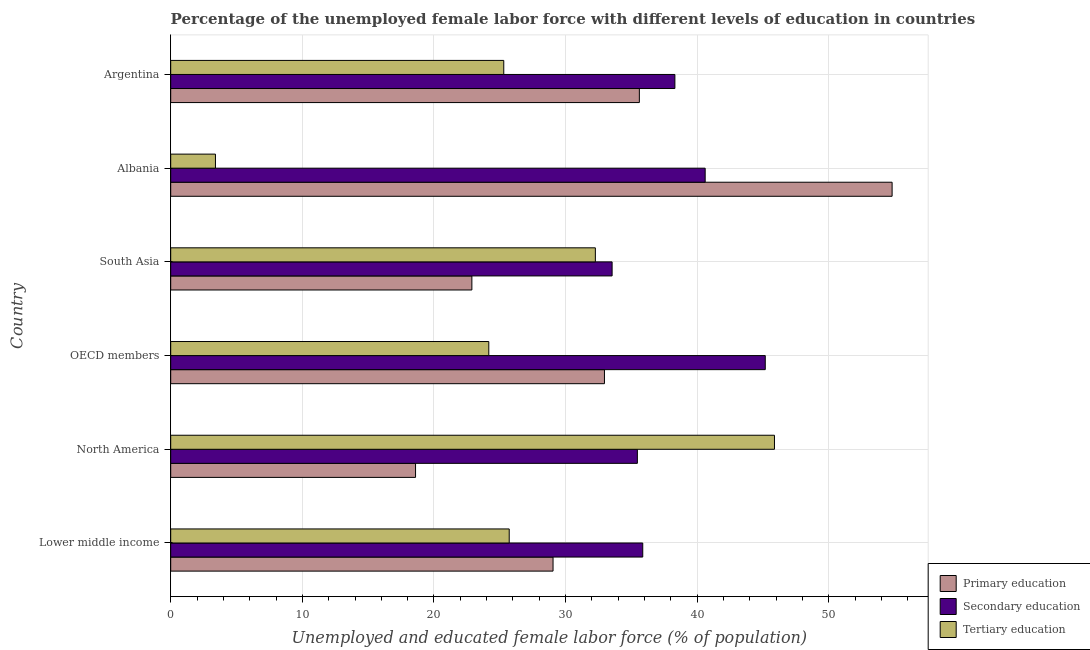How many different coloured bars are there?
Provide a short and direct response. 3. How many bars are there on the 6th tick from the top?
Offer a terse response. 3. How many bars are there on the 3rd tick from the bottom?
Give a very brief answer. 3. What is the label of the 5th group of bars from the top?
Make the answer very short. North America. What is the percentage of female labor force who received primary education in OECD members?
Your response must be concise. 32.95. Across all countries, what is the maximum percentage of female labor force who received secondary education?
Offer a terse response. 45.16. Across all countries, what is the minimum percentage of female labor force who received secondary education?
Your answer should be compact. 33.53. In which country was the percentage of female labor force who received tertiary education minimum?
Give a very brief answer. Albania. What is the total percentage of female labor force who received tertiary education in the graph?
Offer a terse response. 156.7. What is the difference between the percentage of female labor force who received secondary education in Lower middle income and that in North America?
Offer a very short reply. 0.41. What is the difference between the percentage of female labor force who received primary education in Albania and the percentage of female labor force who received tertiary education in North America?
Your answer should be compact. 8.94. What is the average percentage of female labor force who received tertiary education per country?
Offer a very short reply. 26.12. What is the difference between the percentage of female labor force who received secondary education and percentage of female labor force who received tertiary education in Lower middle income?
Offer a very short reply. 10.14. In how many countries, is the percentage of female labor force who received secondary education greater than 46 %?
Make the answer very short. 0. What is the ratio of the percentage of female labor force who received primary education in Lower middle income to that in North America?
Offer a terse response. 1.56. Is the difference between the percentage of female labor force who received primary education in Lower middle income and South Asia greater than the difference between the percentage of female labor force who received secondary education in Lower middle income and South Asia?
Ensure brevity in your answer.  Yes. What is the difference between the highest and the lowest percentage of female labor force who received primary education?
Ensure brevity in your answer.  36.2. What does the 2nd bar from the top in OECD members represents?
Offer a terse response. Secondary education. What does the 2nd bar from the bottom in North America represents?
Provide a short and direct response. Secondary education. How many bars are there?
Keep it short and to the point. 18. How many countries are there in the graph?
Ensure brevity in your answer.  6. What is the difference between two consecutive major ticks on the X-axis?
Provide a succinct answer. 10. Are the values on the major ticks of X-axis written in scientific E-notation?
Keep it short and to the point. No. Does the graph contain any zero values?
Provide a succinct answer. No. Does the graph contain grids?
Your answer should be compact. Yes. Where does the legend appear in the graph?
Your response must be concise. Bottom right. What is the title of the graph?
Provide a succinct answer. Percentage of the unemployed female labor force with different levels of education in countries. What is the label or title of the X-axis?
Give a very brief answer. Unemployed and educated female labor force (% of population). What is the label or title of the Y-axis?
Provide a short and direct response. Country. What is the Unemployed and educated female labor force (% of population) in Primary education in Lower middle income?
Keep it short and to the point. 29.04. What is the Unemployed and educated female labor force (% of population) in Secondary education in Lower middle income?
Your answer should be compact. 35.86. What is the Unemployed and educated female labor force (% of population) of Tertiary education in Lower middle income?
Give a very brief answer. 25.71. What is the Unemployed and educated female labor force (% of population) of Primary education in North America?
Your response must be concise. 18.6. What is the Unemployed and educated female labor force (% of population) of Secondary education in North America?
Offer a terse response. 35.45. What is the Unemployed and educated female labor force (% of population) in Tertiary education in North America?
Give a very brief answer. 45.86. What is the Unemployed and educated female labor force (% of population) in Primary education in OECD members?
Offer a terse response. 32.95. What is the Unemployed and educated female labor force (% of population) of Secondary education in OECD members?
Offer a very short reply. 45.16. What is the Unemployed and educated female labor force (% of population) in Tertiary education in OECD members?
Make the answer very short. 24.16. What is the Unemployed and educated female labor force (% of population) of Primary education in South Asia?
Your response must be concise. 22.88. What is the Unemployed and educated female labor force (% of population) in Secondary education in South Asia?
Provide a succinct answer. 33.53. What is the Unemployed and educated female labor force (% of population) of Tertiary education in South Asia?
Provide a short and direct response. 32.26. What is the Unemployed and educated female labor force (% of population) of Primary education in Albania?
Provide a succinct answer. 54.8. What is the Unemployed and educated female labor force (% of population) of Secondary education in Albania?
Your answer should be compact. 40.6. What is the Unemployed and educated female labor force (% of population) of Tertiary education in Albania?
Give a very brief answer. 3.4. What is the Unemployed and educated female labor force (% of population) of Primary education in Argentina?
Offer a terse response. 35.6. What is the Unemployed and educated female labor force (% of population) of Secondary education in Argentina?
Your answer should be very brief. 38.3. What is the Unemployed and educated female labor force (% of population) in Tertiary education in Argentina?
Ensure brevity in your answer.  25.3. Across all countries, what is the maximum Unemployed and educated female labor force (% of population) in Primary education?
Ensure brevity in your answer.  54.8. Across all countries, what is the maximum Unemployed and educated female labor force (% of population) of Secondary education?
Offer a terse response. 45.16. Across all countries, what is the maximum Unemployed and educated female labor force (% of population) in Tertiary education?
Your answer should be compact. 45.86. Across all countries, what is the minimum Unemployed and educated female labor force (% of population) of Primary education?
Your response must be concise. 18.6. Across all countries, what is the minimum Unemployed and educated female labor force (% of population) of Secondary education?
Offer a terse response. 33.53. Across all countries, what is the minimum Unemployed and educated female labor force (% of population) in Tertiary education?
Make the answer very short. 3.4. What is the total Unemployed and educated female labor force (% of population) in Primary education in the graph?
Keep it short and to the point. 193.87. What is the total Unemployed and educated female labor force (% of population) in Secondary education in the graph?
Your response must be concise. 228.9. What is the total Unemployed and educated female labor force (% of population) in Tertiary education in the graph?
Give a very brief answer. 156.7. What is the difference between the Unemployed and educated female labor force (% of population) of Primary education in Lower middle income and that in North America?
Ensure brevity in your answer.  10.44. What is the difference between the Unemployed and educated female labor force (% of population) of Secondary education in Lower middle income and that in North America?
Your answer should be very brief. 0.41. What is the difference between the Unemployed and educated female labor force (% of population) of Tertiary education in Lower middle income and that in North America?
Provide a short and direct response. -20.15. What is the difference between the Unemployed and educated female labor force (% of population) of Primary education in Lower middle income and that in OECD members?
Your response must be concise. -3.9. What is the difference between the Unemployed and educated female labor force (% of population) in Secondary education in Lower middle income and that in OECD members?
Make the answer very short. -9.31. What is the difference between the Unemployed and educated female labor force (% of population) of Tertiary education in Lower middle income and that in OECD members?
Your response must be concise. 1.55. What is the difference between the Unemployed and educated female labor force (% of population) in Primary education in Lower middle income and that in South Asia?
Ensure brevity in your answer.  6.17. What is the difference between the Unemployed and educated female labor force (% of population) in Secondary education in Lower middle income and that in South Asia?
Give a very brief answer. 2.33. What is the difference between the Unemployed and educated female labor force (% of population) of Tertiary education in Lower middle income and that in South Asia?
Your response must be concise. -6.54. What is the difference between the Unemployed and educated female labor force (% of population) of Primary education in Lower middle income and that in Albania?
Provide a short and direct response. -25.76. What is the difference between the Unemployed and educated female labor force (% of population) in Secondary education in Lower middle income and that in Albania?
Your answer should be very brief. -4.74. What is the difference between the Unemployed and educated female labor force (% of population) of Tertiary education in Lower middle income and that in Albania?
Make the answer very short. 22.31. What is the difference between the Unemployed and educated female labor force (% of population) of Primary education in Lower middle income and that in Argentina?
Your response must be concise. -6.56. What is the difference between the Unemployed and educated female labor force (% of population) in Secondary education in Lower middle income and that in Argentina?
Give a very brief answer. -2.44. What is the difference between the Unemployed and educated female labor force (% of population) of Tertiary education in Lower middle income and that in Argentina?
Your answer should be very brief. 0.41. What is the difference between the Unemployed and educated female labor force (% of population) in Primary education in North America and that in OECD members?
Provide a short and direct response. -14.35. What is the difference between the Unemployed and educated female labor force (% of population) of Secondary education in North America and that in OECD members?
Make the answer very short. -9.72. What is the difference between the Unemployed and educated female labor force (% of population) in Tertiary education in North America and that in OECD members?
Your response must be concise. 21.7. What is the difference between the Unemployed and educated female labor force (% of population) of Primary education in North America and that in South Asia?
Offer a very short reply. -4.28. What is the difference between the Unemployed and educated female labor force (% of population) of Secondary education in North America and that in South Asia?
Ensure brevity in your answer.  1.92. What is the difference between the Unemployed and educated female labor force (% of population) of Tertiary education in North America and that in South Asia?
Offer a very short reply. 13.61. What is the difference between the Unemployed and educated female labor force (% of population) of Primary education in North America and that in Albania?
Keep it short and to the point. -36.2. What is the difference between the Unemployed and educated female labor force (% of population) of Secondary education in North America and that in Albania?
Your answer should be compact. -5.15. What is the difference between the Unemployed and educated female labor force (% of population) of Tertiary education in North America and that in Albania?
Give a very brief answer. 42.46. What is the difference between the Unemployed and educated female labor force (% of population) in Primary education in North America and that in Argentina?
Your answer should be compact. -17. What is the difference between the Unemployed and educated female labor force (% of population) in Secondary education in North America and that in Argentina?
Offer a very short reply. -2.85. What is the difference between the Unemployed and educated female labor force (% of population) of Tertiary education in North America and that in Argentina?
Make the answer very short. 20.56. What is the difference between the Unemployed and educated female labor force (% of population) of Primary education in OECD members and that in South Asia?
Keep it short and to the point. 10.07. What is the difference between the Unemployed and educated female labor force (% of population) in Secondary education in OECD members and that in South Asia?
Give a very brief answer. 11.63. What is the difference between the Unemployed and educated female labor force (% of population) of Tertiary education in OECD members and that in South Asia?
Keep it short and to the point. -8.09. What is the difference between the Unemployed and educated female labor force (% of population) in Primary education in OECD members and that in Albania?
Keep it short and to the point. -21.85. What is the difference between the Unemployed and educated female labor force (% of population) in Secondary education in OECD members and that in Albania?
Offer a very short reply. 4.56. What is the difference between the Unemployed and educated female labor force (% of population) in Tertiary education in OECD members and that in Albania?
Offer a very short reply. 20.76. What is the difference between the Unemployed and educated female labor force (% of population) in Primary education in OECD members and that in Argentina?
Offer a terse response. -2.65. What is the difference between the Unemployed and educated female labor force (% of population) of Secondary education in OECD members and that in Argentina?
Provide a short and direct response. 6.86. What is the difference between the Unemployed and educated female labor force (% of population) in Tertiary education in OECD members and that in Argentina?
Give a very brief answer. -1.14. What is the difference between the Unemployed and educated female labor force (% of population) of Primary education in South Asia and that in Albania?
Provide a short and direct response. -31.92. What is the difference between the Unemployed and educated female labor force (% of population) in Secondary education in South Asia and that in Albania?
Your answer should be compact. -7.07. What is the difference between the Unemployed and educated female labor force (% of population) of Tertiary education in South Asia and that in Albania?
Offer a very short reply. 28.86. What is the difference between the Unemployed and educated female labor force (% of population) of Primary education in South Asia and that in Argentina?
Give a very brief answer. -12.72. What is the difference between the Unemployed and educated female labor force (% of population) of Secondary education in South Asia and that in Argentina?
Your answer should be compact. -4.77. What is the difference between the Unemployed and educated female labor force (% of population) of Tertiary education in South Asia and that in Argentina?
Your answer should be very brief. 6.96. What is the difference between the Unemployed and educated female labor force (% of population) in Secondary education in Albania and that in Argentina?
Ensure brevity in your answer.  2.3. What is the difference between the Unemployed and educated female labor force (% of population) in Tertiary education in Albania and that in Argentina?
Offer a very short reply. -21.9. What is the difference between the Unemployed and educated female labor force (% of population) in Primary education in Lower middle income and the Unemployed and educated female labor force (% of population) in Secondary education in North America?
Offer a very short reply. -6.41. What is the difference between the Unemployed and educated female labor force (% of population) in Primary education in Lower middle income and the Unemployed and educated female labor force (% of population) in Tertiary education in North America?
Provide a succinct answer. -16.82. What is the difference between the Unemployed and educated female labor force (% of population) in Secondary education in Lower middle income and the Unemployed and educated female labor force (% of population) in Tertiary education in North America?
Provide a short and direct response. -10.01. What is the difference between the Unemployed and educated female labor force (% of population) in Primary education in Lower middle income and the Unemployed and educated female labor force (% of population) in Secondary education in OECD members?
Offer a terse response. -16.12. What is the difference between the Unemployed and educated female labor force (% of population) of Primary education in Lower middle income and the Unemployed and educated female labor force (% of population) of Tertiary education in OECD members?
Provide a short and direct response. 4.88. What is the difference between the Unemployed and educated female labor force (% of population) of Secondary education in Lower middle income and the Unemployed and educated female labor force (% of population) of Tertiary education in OECD members?
Provide a succinct answer. 11.69. What is the difference between the Unemployed and educated female labor force (% of population) in Primary education in Lower middle income and the Unemployed and educated female labor force (% of population) in Secondary education in South Asia?
Your response must be concise. -4.49. What is the difference between the Unemployed and educated female labor force (% of population) of Primary education in Lower middle income and the Unemployed and educated female labor force (% of population) of Tertiary education in South Asia?
Your answer should be compact. -3.21. What is the difference between the Unemployed and educated female labor force (% of population) in Secondary education in Lower middle income and the Unemployed and educated female labor force (% of population) in Tertiary education in South Asia?
Offer a very short reply. 3.6. What is the difference between the Unemployed and educated female labor force (% of population) in Primary education in Lower middle income and the Unemployed and educated female labor force (% of population) in Secondary education in Albania?
Your answer should be compact. -11.56. What is the difference between the Unemployed and educated female labor force (% of population) of Primary education in Lower middle income and the Unemployed and educated female labor force (% of population) of Tertiary education in Albania?
Your answer should be very brief. 25.64. What is the difference between the Unemployed and educated female labor force (% of population) in Secondary education in Lower middle income and the Unemployed and educated female labor force (% of population) in Tertiary education in Albania?
Your response must be concise. 32.46. What is the difference between the Unemployed and educated female labor force (% of population) of Primary education in Lower middle income and the Unemployed and educated female labor force (% of population) of Secondary education in Argentina?
Ensure brevity in your answer.  -9.26. What is the difference between the Unemployed and educated female labor force (% of population) of Primary education in Lower middle income and the Unemployed and educated female labor force (% of population) of Tertiary education in Argentina?
Offer a very short reply. 3.74. What is the difference between the Unemployed and educated female labor force (% of population) of Secondary education in Lower middle income and the Unemployed and educated female labor force (% of population) of Tertiary education in Argentina?
Your response must be concise. 10.56. What is the difference between the Unemployed and educated female labor force (% of population) of Primary education in North America and the Unemployed and educated female labor force (% of population) of Secondary education in OECD members?
Your response must be concise. -26.57. What is the difference between the Unemployed and educated female labor force (% of population) of Primary education in North America and the Unemployed and educated female labor force (% of population) of Tertiary education in OECD members?
Your answer should be very brief. -5.56. What is the difference between the Unemployed and educated female labor force (% of population) of Secondary education in North America and the Unemployed and educated female labor force (% of population) of Tertiary education in OECD members?
Your answer should be compact. 11.29. What is the difference between the Unemployed and educated female labor force (% of population) of Primary education in North America and the Unemployed and educated female labor force (% of population) of Secondary education in South Asia?
Provide a succinct answer. -14.93. What is the difference between the Unemployed and educated female labor force (% of population) of Primary education in North America and the Unemployed and educated female labor force (% of population) of Tertiary education in South Asia?
Your response must be concise. -13.66. What is the difference between the Unemployed and educated female labor force (% of population) of Secondary education in North America and the Unemployed and educated female labor force (% of population) of Tertiary education in South Asia?
Your answer should be compact. 3.19. What is the difference between the Unemployed and educated female labor force (% of population) of Primary education in North America and the Unemployed and educated female labor force (% of population) of Secondary education in Albania?
Offer a terse response. -22. What is the difference between the Unemployed and educated female labor force (% of population) in Primary education in North America and the Unemployed and educated female labor force (% of population) in Tertiary education in Albania?
Keep it short and to the point. 15.2. What is the difference between the Unemployed and educated female labor force (% of population) of Secondary education in North America and the Unemployed and educated female labor force (% of population) of Tertiary education in Albania?
Make the answer very short. 32.05. What is the difference between the Unemployed and educated female labor force (% of population) in Primary education in North America and the Unemployed and educated female labor force (% of population) in Secondary education in Argentina?
Your answer should be compact. -19.7. What is the difference between the Unemployed and educated female labor force (% of population) of Primary education in North America and the Unemployed and educated female labor force (% of population) of Tertiary education in Argentina?
Provide a succinct answer. -6.7. What is the difference between the Unemployed and educated female labor force (% of population) of Secondary education in North America and the Unemployed and educated female labor force (% of population) of Tertiary education in Argentina?
Give a very brief answer. 10.15. What is the difference between the Unemployed and educated female labor force (% of population) in Primary education in OECD members and the Unemployed and educated female labor force (% of population) in Secondary education in South Asia?
Offer a terse response. -0.58. What is the difference between the Unemployed and educated female labor force (% of population) of Primary education in OECD members and the Unemployed and educated female labor force (% of population) of Tertiary education in South Asia?
Provide a short and direct response. 0.69. What is the difference between the Unemployed and educated female labor force (% of population) of Secondary education in OECD members and the Unemployed and educated female labor force (% of population) of Tertiary education in South Asia?
Your answer should be compact. 12.91. What is the difference between the Unemployed and educated female labor force (% of population) of Primary education in OECD members and the Unemployed and educated female labor force (% of population) of Secondary education in Albania?
Provide a short and direct response. -7.65. What is the difference between the Unemployed and educated female labor force (% of population) of Primary education in OECD members and the Unemployed and educated female labor force (% of population) of Tertiary education in Albania?
Provide a short and direct response. 29.55. What is the difference between the Unemployed and educated female labor force (% of population) of Secondary education in OECD members and the Unemployed and educated female labor force (% of population) of Tertiary education in Albania?
Provide a short and direct response. 41.76. What is the difference between the Unemployed and educated female labor force (% of population) of Primary education in OECD members and the Unemployed and educated female labor force (% of population) of Secondary education in Argentina?
Make the answer very short. -5.35. What is the difference between the Unemployed and educated female labor force (% of population) in Primary education in OECD members and the Unemployed and educated female labor force (% of population) in Tertiary education in Argentina?
Keep it short and to the point. 7.65. What is the difference between the Unemployed and educated female labor force (% of population) in Secondary education in OECD members and the Unemployed and educated female labor force (% of population) in Tertiary education in Argentina?
Make the answer very short. 19.86. What is the difference between the Unemployed and educated female labor force (% of population) in Primary education in South Asia and the Unemployed and educated female labor force (% of population) in Secondary education in Albania?
Keep it short and to the point. -17.72. What is the difference between the Unemployed and educated female labor force (% of population) of Primary education in South Asia and the Unemployed and educated female labor force (% of population) of Tertiary education in Albania?
Make the answer very short. 19.48. What is the difference between the Unemployed and educated female labor force (% of population) in Secondary education in South Asia and the Unemployed and educated female labor force (% of population) in Tertiary education in Albania?
Offer a very short reply. 30.13. What is the difference between the Unemployed and educated female labor force (% of population) in Primary education in South Asia and the Unemployed and educated female labor force (% of population) in Secondary education in Argentina?
Offer a terse response. -15.42. What is the difference between the Unemployed and educated female labor force (% of population) of Primary education in South Asia and the Unemployed and educated female labor force (% of population) of Tertiary education in Argentina?
Provide a short and direct response. -2.42. What is the difference between the Unemployed and educated female labor force (% of population) in Secondary education in South Asia and the Unemployed and educated female labor force (% of population) in Tertiary education in Argentina?
Ensure brevity in your answer.  8.23. What is the difference between the Unemployed and educated female labor force (% of population) of Primary education in Albania and the Unemployed and educated female labor force (% of population) of Secondary education in Argentina?
Your answer should be very brief. 16.5. What is the difference between the Unemployed and educated female labor force (% of population) of Primary education in Albania and the Unemployed and educated female labor force (% of population) of Tertiary education in Argentina?
Give a very brief answer. 29.5. What is the difference between the Unemployed and educated female labor force (% of population) of Secondary education in Albania and the Unemployed and educated female labor force (% of population) of Tertiary education in Argentina?
Make the answer very short. 15.3. What is the average Unemployed and educated female labor force (% of population) in Primary education per country?
Provide a succinct answer. 32.31. What is the average Unemployed and educated female labor force (% of population) of Secondary education per country?
Make the answer very short. 38.15. What is the average Unemployed and educated female labor force (% of population) in Tertiary education per country?
Give a very brief answer. 26.12. What is the difference between the Unemployed and educated female labor force (% of population) in Primary education and Unemployed and educated female labor force (% of population) in Secondary education in Lower middle income?
Provide a succinct answer. -6.81. What is the difference between the Unemployed and educated female labor force (% of population) of Primary education and Unemployed and educated female labor force (% of population) of Tertiary education in Lower middle income?
Your answer should be very brief. 3.33. What is the difference between the Unemployed and educated female labor force (% of population) in Secondary education and Unemployed and educated female labor force (% of population) in Tertiary education in Lower middle income?
Provide a short and direct response. 10.14. What is the difference between the Unemployed and educated female labor force (% of population) in Primary education and Unemployed and educated female labor force (% of population) in Secondary education in North America?
Offer a terse response. -16.85. What is the difference between the Unemployed and educated female labor force (% of population) in Primary education and Unemployed and educated female labor force (% of population) in Tertiary education in North America?
Offer a terse response. -27.26. What is the difference between the Unemployed and educated female labor force (% of population) in Secondary education and Unemployed and educated female labor force (% of population) in Tertiary education in North America?
Keep it short and to the point. -10.41. What is the difference between the Unemployed and educated female labor force (% of population) of Primary education and Unemployed and educated female labor force (% of population) of Secondary education in OECD members?
Your answer should be very brief. -12.22. What is the difference between the Unemployed and educated female labor force (% of population) of Primary education and Unemployed and educated female labor force (% of population) of Tertiary education in OECD members?
Give a very brief answer. 8.78. What is the difference between the Unemployed and educated female labor force (% of population) of Secondary education and Unemployed and educated female labor force (% of population) of Tertiary education in OECD members?
Provide a succinct answer. 21. What is the difference between the Unemployed and educated female labor force (% of population) in Primary education and Unemployed and educated female labor force (% of population) in Secondary education in South Asia?
Your response must be concise. -10.65. What is the difference between the Unemployed and educated female labor force (% of population) in Primary education and Unemployed and educated female labor force (% of population) in Tertiary education in South Asia?
Offer a terse response. -9.38. What is the difference between the Unemployed and educated female labor force (% of population) of Secondary education and Unemployed and educated female labor force (% of population) of Tertiary education in South Asia?
Your answer should be very brief. 1.27. What is the difference between the Unemployed and educated female labor force (% of population) of Primary education and Unemployed and educated female labor force (% of population) of Tertiary education in Albania?
Your response must be concise. 51.4. What is the difference between the Unemployed and educated female labor force (% of population) of Secondary education and Unemployed and educated female labor force (% of population) of Tertiary education in Albania?
Your response must be concise. 37.2. What is the difference between the Unemployed and educated female labor force (% of population) in Primary education and Unemployed and educated female labor force (% of population) in Tertiary education in Argentina?
Your answer should be very brief. 10.3. What is the ratio of the Unemployed and educated female labor force (% of population) in Primary education in Lower middle income to that in North America?
Provide a short and direct response. 1.56. What is the ratio of the Unemployed and educated female labor force (% of population) in Secondary education in Lower middle income to that in North America?
Make the answer very short. 1.01. What is the ratio of the Unemployed and educated female labor force (% of population) in Tertiary education in Lower middle income to that in North America?
Ensure brevity in your answer.  0.56. What is the ratio of the Unemployed and educated female labor force (% of population) of Primary education in Lower middle income to that in OECD members?
Your answer should be very brief. 0.88. What is the ratio of the Unemployed and educated female labor force (% of population) of Secondary education in Lower middle income to that in OECD members?
Your answer should be very brief. 0.79. What is the ratio of the Unemployed and educated female labor force (% of population) of Tertiary education in Lower middle income to that in OECD members?
Offer a very short reply. 1.06. What is the ratio of the Unemployed and educated female labor force (% of population) of Primary education in Lower middle income to that in South Asia?
Provide a short and direct response. 1.27. What is the ratio of the Unemployed and educated female labor force (% of population) in Secondary education in Lower middle income to that in South Asia?
Provide a succinct answer. 1.07. What is the ratio of the Unemployed and educated female labor force (% of population) in Tertiary education in Lower middle income to that in South Asia?
Keep it short and to the point. 0.8. What is the ratio of the Unemployed and educated female labor force (% of population) of Primary education in Lower middle income to that in Albania?
Provide a short and direct response. 0.53. What is the ratio of the Unemployed and educated female labor force (% of population) in Secondary education in Lower middle income to that in Albania?
Provide a short and direct response. 0.88. What is the ratio of the Unemployed and educated female labor force (% of population) in Tertiary education in Lower middle income to that in Albania?
Provide a short and direct response. 7.56. What is the ratio of the Unemployed and educated female labor force (% of population) in Primary education in Lower middle income to that in Argentina?
Keep it short and to the point. 0.82. What is the ratio of the Unemployed and educated female labor force (% of population) in Secondary education in Lower middle income to that in Argentina?
Offer a very short reply. 0.94. What is the ratio of the Unemployed and educated female labor force (% of population) in Tertiary education in Lower middle income to that in Argentina?
Make the answer very short. 1.02. What is the ratio of the Unemployed and educated female labor force (% of population) of Primary education in North America to that in OECD members?
Offer a very short reply. 0.56. What is the ratio of the Unemployed and educated female labor force (% of population) in Secondary education in North America to that in OECD members?
Ensure brevity in your answer.  0.78. What is the ratio of the Unemployed and educated female labor force (% of population) in Tertiary education in North America to that in OECD members?
Your answer should be very brief. 1.9. What is the ratio of the Unemployed and educated female labor force (% of population) of Primary education in North America to that in South Asia?
Your answer should be compact. 0.81. What is the ratio of the Unemployed and educated female labor force (% of population) of Secondary education in North America to that in South Asia?
Your answer should be very brief. 1.06. What is the ratio of the Unemployed and educated female labor force (% of population) of Tertiary education in North America to that in South Asia?
Your answer should be compact. 1.42. What is the ratio of the Unemployed and educated female labor force (% of population) in Primary education in North America to that in Albania?
Offer a very short reply. 0.34. What is the ratio of the Unemployed and educated female labor force (% of population) in Secondary education in North America to that in Albania?
Provide a short and direct response. 0.87. What is the ratio of the Unemployed and educated female labor force (% of population) of Tertiary education in North America to that in Albania?
Keep it short and to the point. 13.49. What is the ratio of the Unemployed and educated female labor force (% of population) in Primary education in North America to that in Argentina?
Keep it short and to the point. 0.52. What is the ratio of the Unemployed and educated female labor force (% of population) of Secondary education in North America to that in Argentina?
Your answer should be compact. 0.93. What is the ratio of the Unemployed and educated female labor force (% of population) in Tertiary education in North America to that in Argentina?
Offer a terse response. 1.81. What is the ratio of the Unemployed and educated female labor force (% of population) of Primary education in OECD members to that in South Asia?
Ensure brevity in your answer.  1.44. What is the ratio of the Unemployed and educated female labor force (% of population) of Secondary education in OECD members to that in South Asia?
Give a very brief answer. 1.35. What is the ratio of the Unemployed and educated female labor force (% of population) of Tertiary education in OECD members to that in South Asia?
Provide a succinct answer. 0.75. What is the ratio of the Unemployed and educated female labor force (% of population) of Primary education in OECD members to that in Albania?
Offer a very short reply. 0.6. What is the ratio of the Unemployed and educated female labor force (% of population) of Secondary education in OECD members to that in Albania?
Provide a short and direct response. 1.11. What is the ratio of the Unemployed and educated female labor force (% of population) in Tertiary education in OECD members to that in Albania?
Make the answer very short. 7.11. What is the ratio of the Unemployed and educated female labor force (% of population) of Primary education in OECD members to that in Argentina?
Ensure brevity in your answer.  0.93. What is the ratio of the Unemployed and educated female labor force (% of population) of Secondary education in OECD members to that in Argentina?
Offer a very short reply. 1.18. What is the ratio of the Unemployed and educated female labor force (% of population) of Tertiary education in OECD members to that in Argentina?
Your response must be concise. 0.96. What is the ratio of the Unemployed and educated female labor force (% of population) in Primary education in South Asia to that in Albania?
Your response must be concise. 0.42. What is the ratio of the Unemployed and educated female labor force (% of population) in Secondary education in South Asia to that in Albania?
Give a very brief answer. 0.83. What is the ratio of the Unemployed and educated female labor force (% of population) of Tertiary education in South Asia to that in Albania?
Provide a short and direct response. 9.49. What is the ratio of the Unemployed and educated female labor force (% of population) in Primary education in South Asia to that in Argentina?
Give a very brief answer. 0.64. What is the ratio of the Unemployed and educated female labor force (% of population) of Secondary education in South Asia to that in Argentina?
Give a very brief answer. 0.88. What is the ratio of the Unemployed and educated female labor force (% of population) of Tertiary education in South Asia to that in Argentina?
Offer a terse response. 1.27. What is the ratio of the Unemployed and educated female labor force (% of population) of Primary education in Albania to that in Argentina?
Your answer should be compact. 1.54. What is the ratio of the Unemployed and educated female labor force (% of population) of Secondary education in Albania to that in Argentina?
Give a very brief answer. 1.06. What is the ratio of the Unemployed and educated female labor force (% of population) in Tertiary education in Albania to that in Argentina?
Ensure brevity in your answer.  0.13. What is the difference between the highest and the second highest Unemployed and educated female labor force (% of population) in Primary education?
Provide a succinct answer. 19.2. What is the difference between the highest and the second highest Unemployed and educated female labor force (% of population) in Secondary education?
Your response must be concise. 4.56. What is the difference between the highest and the second highest Unemployed and educated female labor force (% of population) of Tertiary education?
Your answer should be compact. 13.61. What is the difference between the highest and the lowest Unemployed and educated female labor force (% of population) of Primary education?
Provide a succinct answer. 36.2. What is the difference between the highest and the lowest Unemployed and educated female labor force (% of population) in Secondary education?
Offer a very short reply. 11.63. What is the difference between the highest and the lowest Unemployed and educated female labor force (% of population) in Tertiary education?
Ensure brevity in your answer.  42.46. 